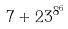Convert formula to latex. <formula><loc_0><loc_0><loc_500><loc_500>7 + 2 3 ^ { 8 ^ { 6 } }</formula> 